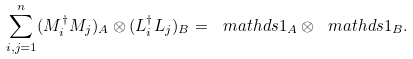Convert formula to latex. <formula><loc_0><loc_0><loc_500><loc_500>\sum _ { i , j = 1 } ^ { n } ( M _ { i } ^ { \dagger } M _ { j } ) _ { A } \otimes ( L _ { i } ^ { \dagger } L _ { j } ) _ { B } = \ m a t h d s { 1 } _ { A } \otimes \ m a t h d s { 1 } _ { B } .</formula> 